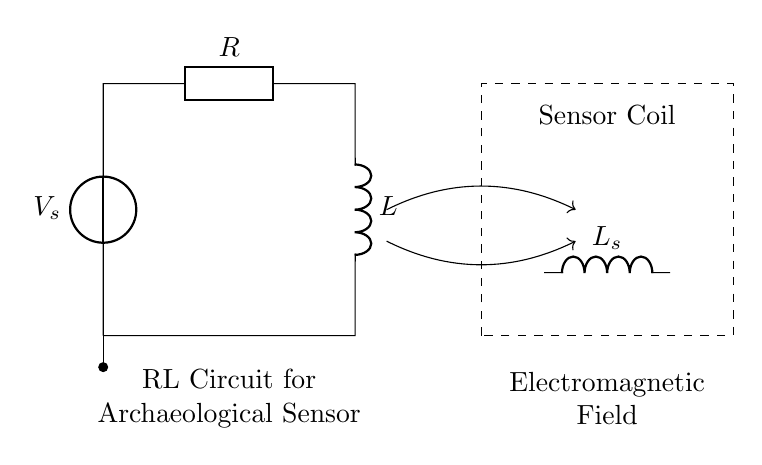What components are in the circuit? The circuit contains a voltage source, a resistor, and an inductor. Each of these components plays a role in how the RL circuit operates. The voltage source provides the necessary electrical potential, the resistor limits current flow, and the inductor stores energy in a magnetic field.
Answer: Voltage source, resistor, inductor What is the purpose of the dashed rectangle? The dashed rectangle represents the sensor coil, indicating that it is a separate component in the circuit. This component is specifically used in electromagnetic applications, such as archaeological site exploration, to detect magnetic fields or changes in those fields.
Answer: Sensor coil Which component stores energy in the magnetic field? The inductor is the component responsible for storing energy in the magnetic field. When current flows through an inductor, it creates a magnetic field around it, which can store energy for later use, unlike a resistor, which dissipates energy as heat.
Answer: Inductor What is the role of the resistor in this circuit? The resistor in this circuit limits the amount of current that can flow. It provides a degree of control over how the circuit behaves, affecting the charging and discharging time of the inductor and thus influencing the overall response of the RL circuit.
Answer: Limits current How does the inductor affect the circuit behavior during oscillation? During oscillation in an RL circuit, the inductor creates a phase shift between voltage and current. This shift affects the timing of when energy is stored and released, thereby controlling the oscillation frequency, which is essential for sensor applications in detecting changes in electromagnetic fields.
Answer: Creates phase shift What effect does increasing the inductance have on the circuit's response? Increasing the inductance will slow down the response time of the circuit, as larger inductance means more energy storage capacity, which leads to a longer time constant in the RL circuit. This slow response can affect how well the system detects rapid changes in parameters.
Answer: Slows response time 